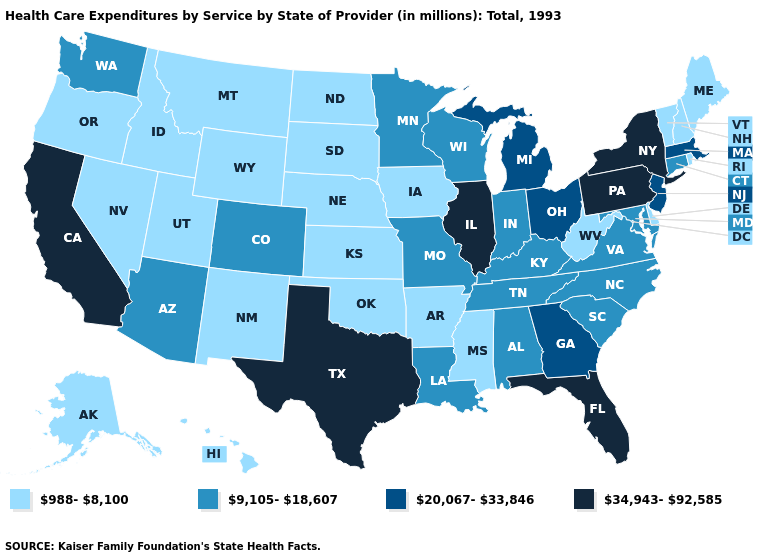Name the states that have a value in the range 988-8,100?
Answer briefly. Alaska, Arkansas, Delaware, Hawaii, Idaho, Iowa, Kansas, Maine, Mississippi, Montana, Nebraska, Nevada, New Hampshire, New Mexico, North Dakota, Oklahoma, Oregon, Rhode Island, South Dakota, Utah, Vermont, West Virginia, Wyoming. Name the states that have a value in the range 20,067-33,846?
Answer briefly. Georgia, Massachusetts, Michigan, New Jersey, Ohio. What is the highest value in the USA?
Concise answer only. 34,943-92,585. Which states have the lowest value in the USA?
Give a very brief answer. Alaska, Arkansas, Delaware, Hawaii, Idaho, Iowa, Kansas, Maine, Mississippi, Montana, Nebraska, Nevada, New Hampshire, New Mexico, North Dakota, Oklahoma, Oregon, Rhode Island, South Dakota, Utah, Vermont, West Virginia, Wyoming. Does Virginia have the same value as Oregon?
Give a very brief answer. No. What is the highest value in the USA?
Give a very brief answer. 34,943-92,585. Among the states that border Colorado , does Utah have the highest value?
Concise answer only. No. Which states have the highest value in the USA?
Concise answer only. California, Florida, Illinois, New York, Pennsylvania, Texas. What is the highest value in states that border Idaho?
Keep it brief. 9,105-18,607. Name the states that have a value in the range 20,067-33,846?
Keep it brief. Georgia, Massachusetts, Michigan, New Jersey, Ohio. Name the states that have a value in the range 9,105-18,607?
Be succinct. Alabama, Arizona, Colorado, Connecticut, Indiana, Kentucky, Louisiana, Maryland, Minnesota, Missouri, North Carolina, South Carolina, Tennessee, Virginia, Washington, Wisconsin. What is the highest value in the West ?
Give a very brief answer. 34,943-92,585. What is the value of South Dakota?
Be succinct. 988-8,100. What is the highest value in the South ?
Quick response, please. 34,943-92,585. Does Ohio have the lowest value in the MidWest?
Be succinct. No. 